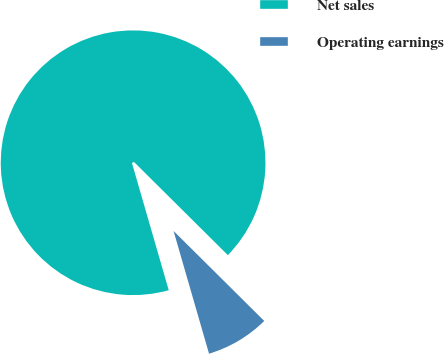Convert chart to OTSL. <chart><loc_0><loc_0><loc_500><loc_500><pie_chart><fcel>Net sales<fcel>Operating earnings<nl><fcel>91.92%<fcel>8.08%<nl></chart> 